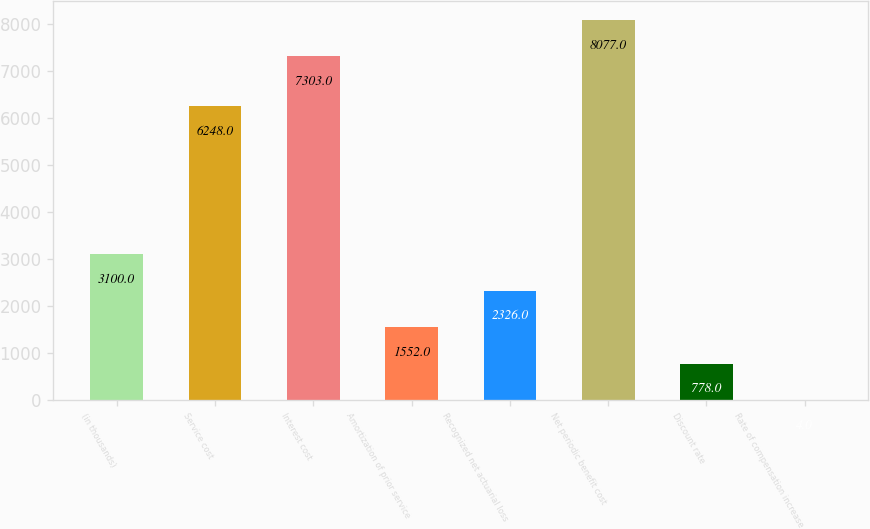Convert chart to OTSL. <chart><loc_0><loc_0><loc_500><loc_500><bar_chart><fcel>(in thousands)<fcel>Service cost<fcel>Interest cost<fcel>Amortization of prior service<fcel>Recognized net actuarial loss<fcel>Net periodic benefit cost<fcel>Discount rate<fcel>Rate of compensation increase<nl><fcel>3100<fcel>6248<fcel>7303<fcel>1552<fcel>2326<fcel>8077<fcel>778<fcel>4<nl></chart> 